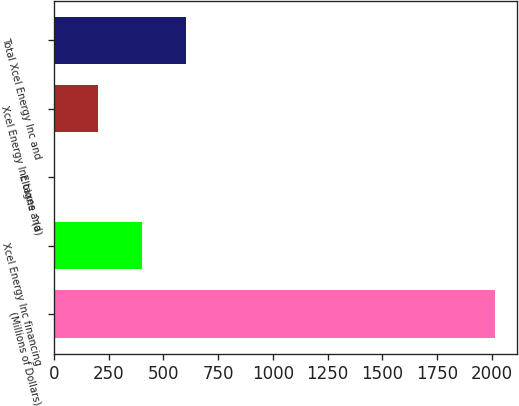Convert chart to OTSL. <chart><loc_0><loc_0><loc_500><loc_500><bar_chart><fcel>(Millions of Dollars)<fcel>Xcel Energy Inc financing<fcel>Eloigne ^(a)<fcel>Xcel Energy Inc taxes and<fcel>Total Xcel Energy Inc and<nl><fcel>2014<fcel>403.2<fcel>0.5<fcel>201.85<fcel>604.55<nl></chart> 